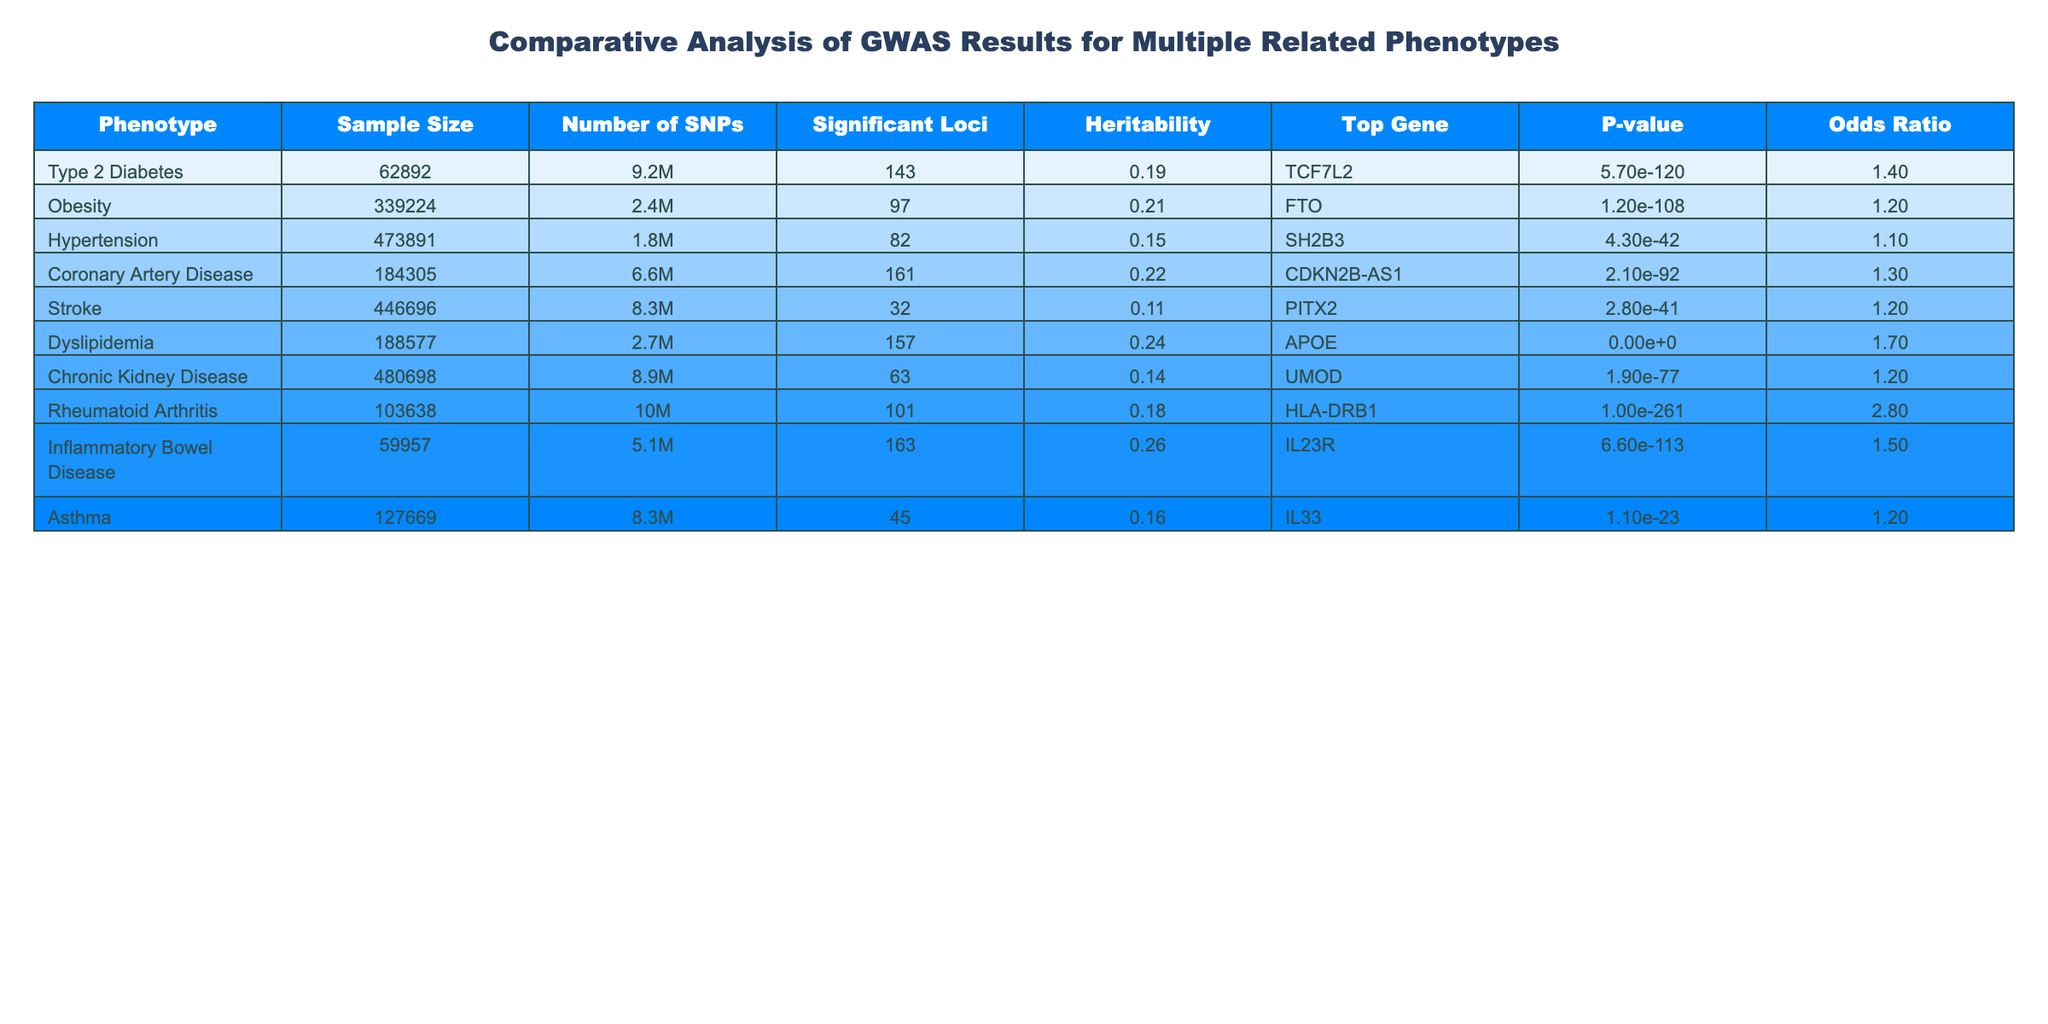What is the sample size for Hypertension? The sample size for Hypertension is listed directly in the table under the "Sample Size" column.
Answer: 473891 Which phenotype has the highest heritability? By comparing the heritability values in the table, Inflammatory Bowel Disease has the highest value of 0.26.
Answer: Inflammatory Bowel Disease How many significant loci are identified for Chronic Kidney Disease? The number of significant loci for Chronic Kidney Disease can be found in the "Significant Loci" column, which shows 63.
Answer: 63 What is the top gene for Obesity? The top gene for Obesity is provided in the "Top Gene" column, which lists FTO.
Answer: FTO Which phenotype has the lowest odds ratio? The odds ratio for each phenotype is given in the "Odds Ratio" column. Hypertension has the lowest odds ratio of 1.1.
Answer: Hypertension What is the average number of SNPs across all phenotypes? First, sum the number of SNPs for each phenotype (9.2M + 2.4M + 1.8M + 6.6M + 8.3M + 2.7M + 8.9M + 10M + 5.1M + 8.3M = 63.2M). Then divide by the number of phenotypes (10). So, the average is 63.2M / 10 = 6.32M.
Answer: 6.32M Is the P-value for Type 2 Diabetes less than that for Stroke? The P-value for Type 2 Diabetes (5.7e-120) is indeed less than that for Stroke (2.8e-41), confirming that Type 2 Diabetes has a more significant association.
Answer: Yes How does the heritability of Dyslipidemia compare to that of Stroke? The heritability of Dyslipidemia is 0.24, while that of Stroke is 0.11. This comparison shows that Dyslipidemia has higher heritability than Stroke.
Answer: Higher What is the total number of significant loci for all the phenotypes combined? The total number of significant loci is found by adding the values: 143 + 97 + 82 + 161 + 32 + 157 + 63 + 101 + 163 + 45 = 1,041.
Answer: 1041 Which phenotype with more than 400,000 samples has the highest number of significant loci? Looking through the phenotypes with sample sizes greater than 400,000, Chronic Kidney Disease (63) has fewer significant loci than Dyslipidemia (157), thus Dyslipidemia has the highest significant loci count among those phenotypes.
Answer: Dyslipidemia 